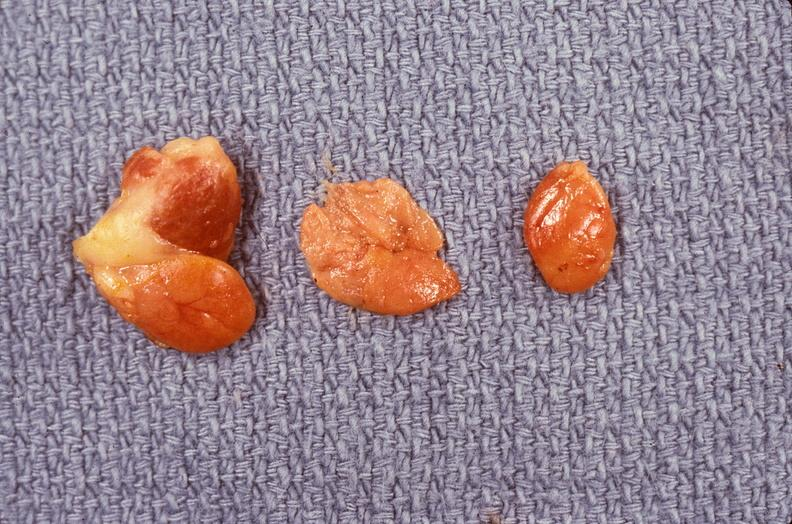does side show parathyroid hyperplasia?
Answer the question using a single word or phrase. No 